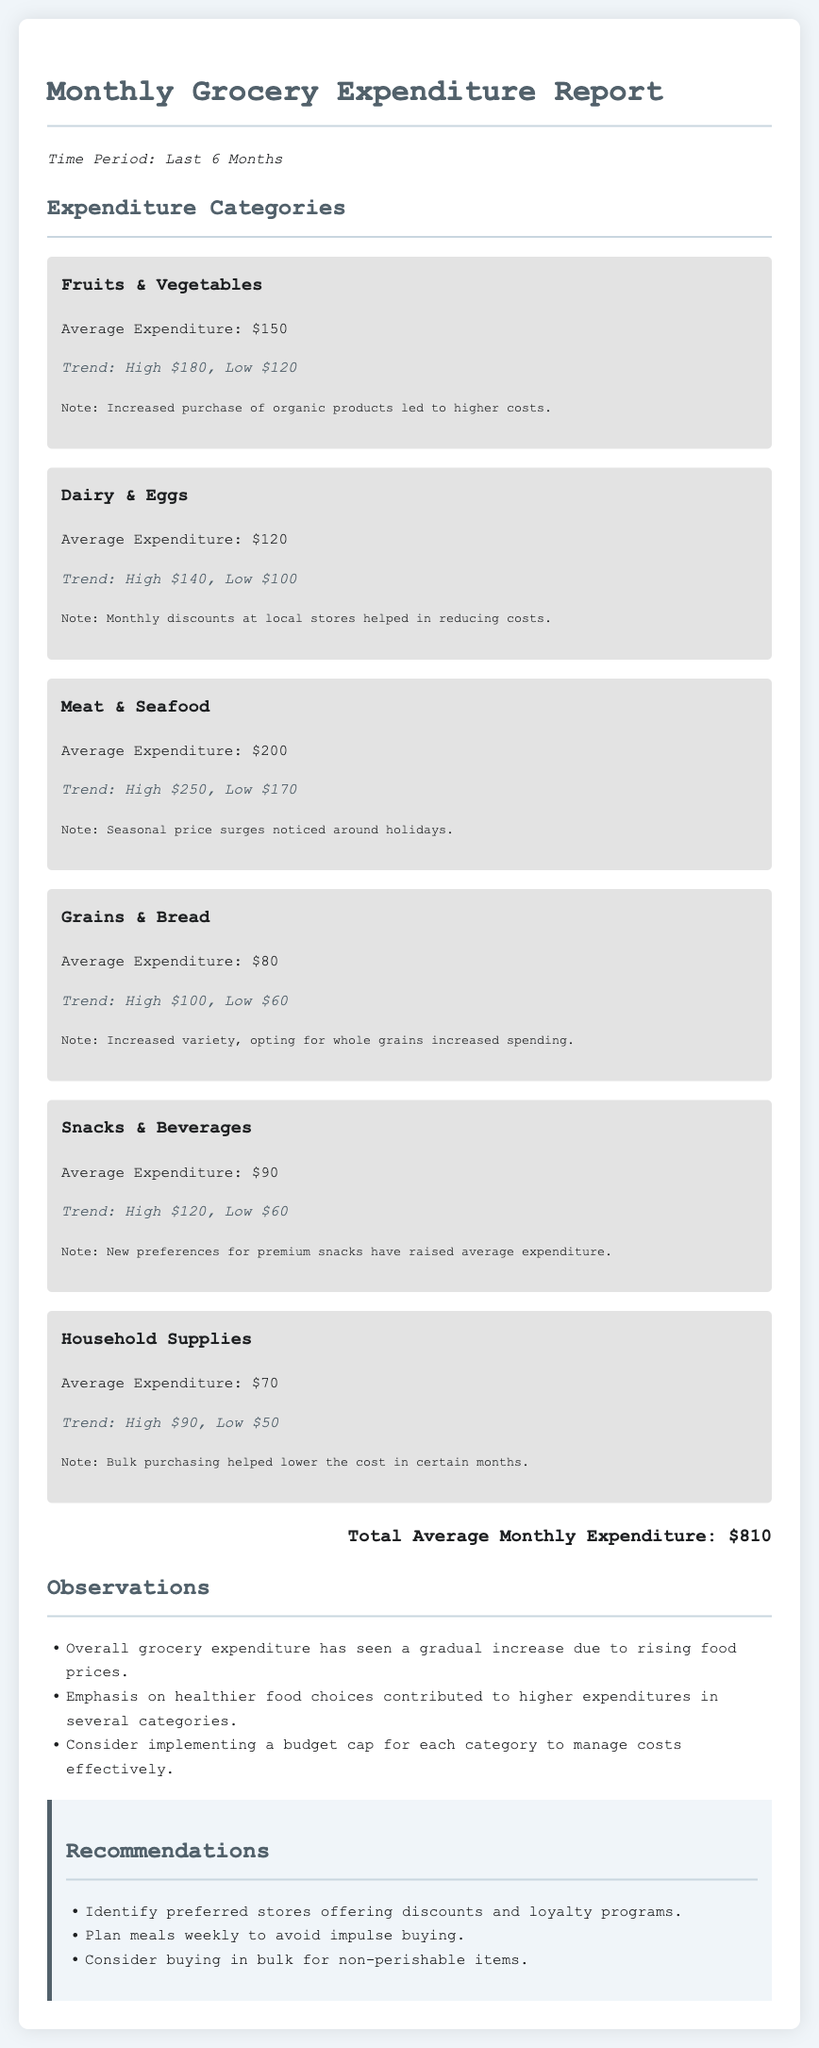What is the average expenditure on Fruits & Vegetables? The average expenditure for this category is provided as part of the expenditure categories section.
Answer: $150 What is the highest recorded expenditure for Meat & Seafood? The highest expenditure detail in the trends for this category shows its highest point.
Answer: $250 What has contributed to the increase in the Grains & Bread category? The note under this category explains that increased variety and opting for whole grains led to higher spending.
Answer: Increased variety, opting for whole grains What is the total average monthly expenditure? The total average monthly expenditure is highlighted at the end of the report.
Answer: $810 What recommendation is made regarding impulse buying? This recommendation is mentioned in the recommendations section, encouraging better shopping habits.
Answer: Plan meals weekly What was the average expenditure for Dairy & Eggs? The average spending for this category is specifically mentioned in the document.
Answer: $120 How did discounts affect Dairy & Eggs expenditure? The note in the Dairy & Eggs category explains how discounts at local stores had a positive impact.
Answer: Helped in reducing costs What does the overall trend in grocery expenditure show? The observations section summarizes the trend in grocery expenditure over the last six months.
Answer: Gradual increase due to rising food prices What is noted about bulk purchasing in Household Supplies? The note for this category mentions the impact of bulk purchasing on costs.
Answer: Helped lower the cost in certain months 